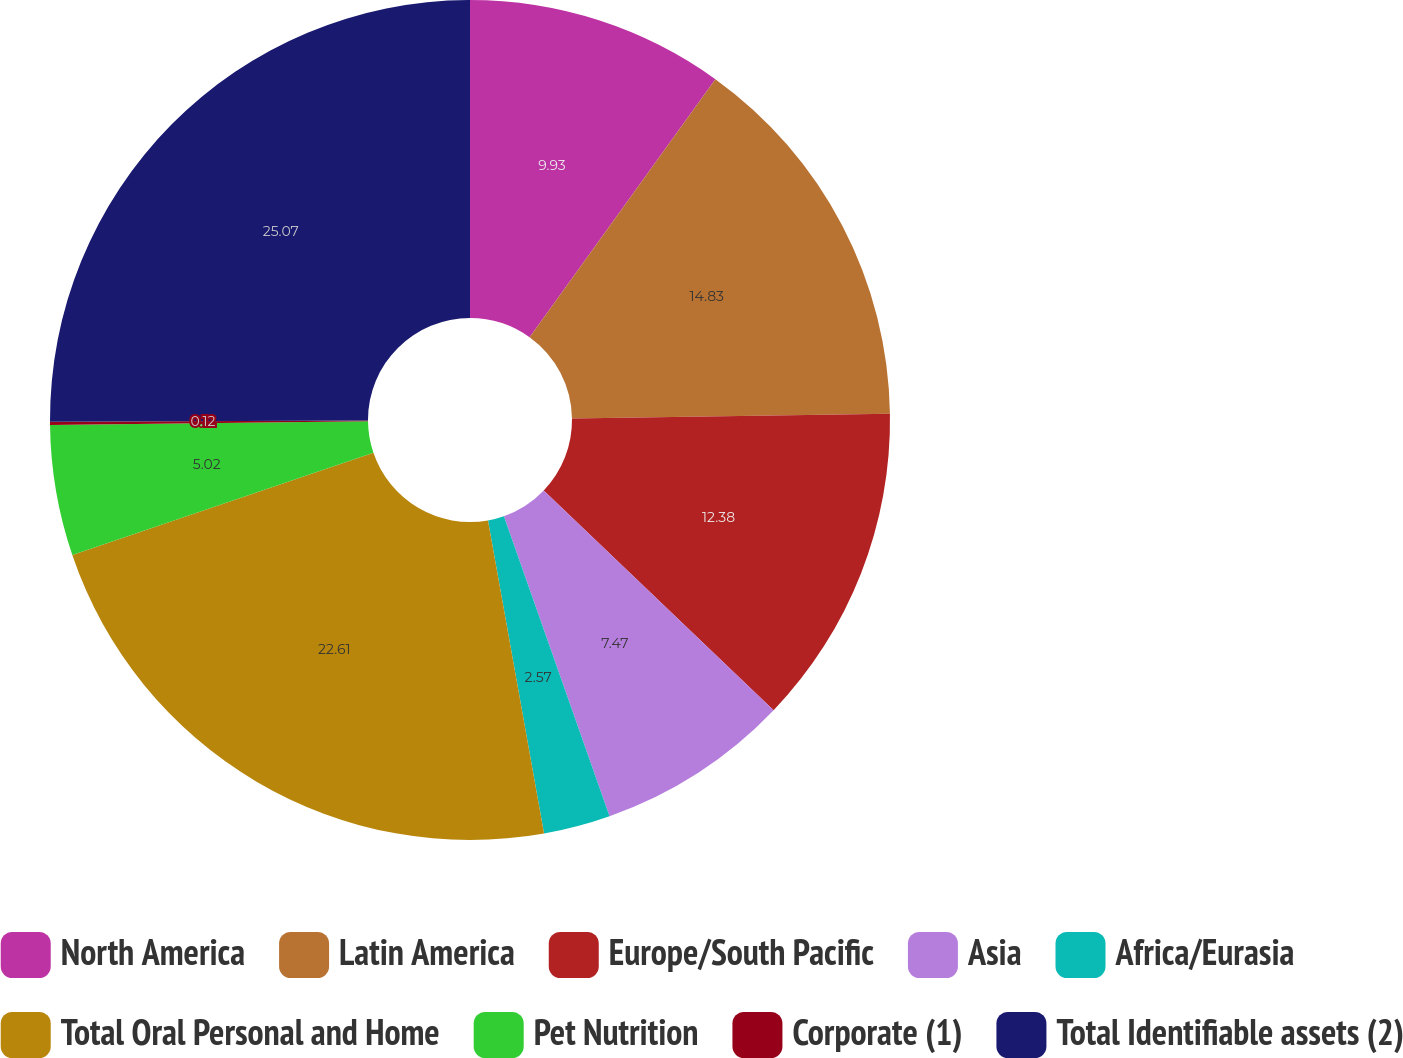Convert chart. <chart><loc_0><loc_0><loc_500><loc_500><pie_chart><fcel>North America<fcel>Latin America<fcel>Europe/South Pacific<fcel>Asia<fcel>Africa/Eurasia<fcel>Total Oral Personal and Home<fcel>Pet Nutrition<fcel>Corporate (1)<fcel>Total Identifiable assets (2)<nl><fcel>9.93%<fcel>14.83%<fcel>12.38%<fcel>7.47%<fcel>2.57%<fcel>22.61%<fcel>5.02%<fcel>0.12%<fcel>25.07%<nl></chart> 